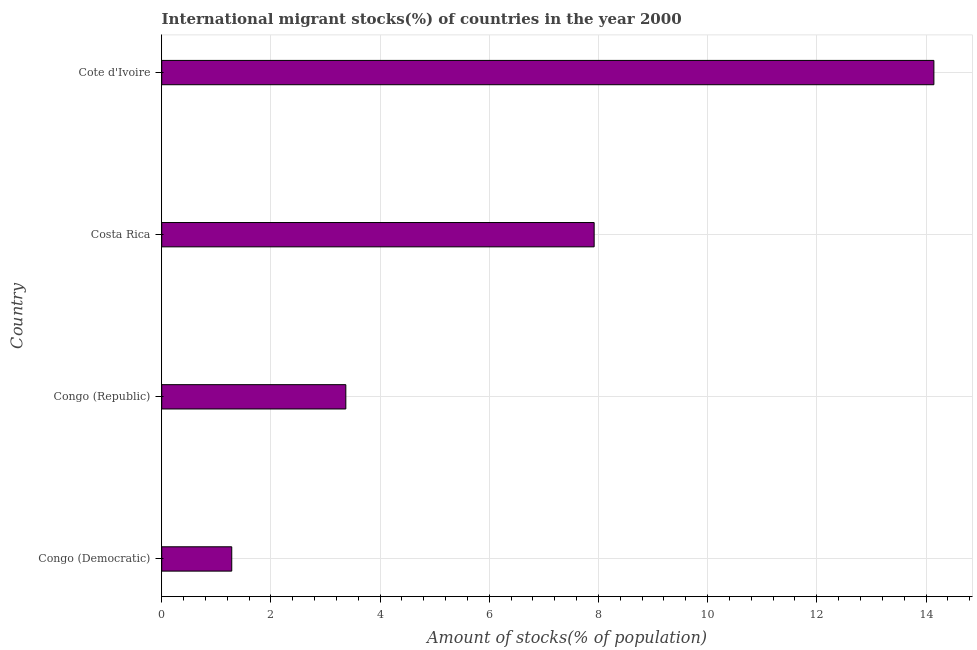What is the title of the graph?
Give a very brief answer. International migrant stocks(%) of countries in the year 2000. What is the label or title of the X-axis?
Your answer should be compact. Amount of stocks(% of population). What is the number of international migrant stocks in Congo (Republic)?
Your response must be concise. 3.37. Across all countries, what is the maximum number of international migrant stocks?
Ensure brevity in your answer.  14.14. Across all countries, what is the minimum number of international migrant stocks?
Provide a succinct answer. 1.28. In which country was the number of international migrant stocks maximum?
Your answer should be compact. Cote d'Ivoire. In which country was the number of international migrant stocks minimum?
Offer a terse response. Congo (Democratic). What is the sum of the number of international migrant stocks?
Keep it short and to the point. 26.72. What is the difference between the number of international migrant stocks in Costa Rica and Cote d'Ivoire?
Provide a succinct answer. -6.22. What is the average number of international migrant stocks per country?
Your response must be concise. 6.68. What is the median number of international migrant stocks?
Offer a terse response. 5.65. In how many countries, is the number of international migrant stocks greater than 1.2 %?
Make the answer very short. 4. What is the ratio of the number of international migrant stocks in Costa Rica to that in Cote d'Ivoire?
Ensure brevity in your answer.  0.56. Is the number of international migrant stocks in Congo (Democratic) less than that in Cote d'Ivoire?
Make the answer very short. Yes. Is the difference between the number of international migrant stocks in Congo (Republic) and Costa Rica greater than the difference between any two countries?
Your answer should be compact. No. What is the difference between the highest and the second highest number of international migrant stocks?
Give a very brief answer. 6.22. Is the sum of the number of international migrant stocks in Congo (Republic) and Cote d'Ivoire greater than the maximum number of international migrant stocks across all countries?
Provide a short and direct response. Yes. What is the difference between the highest and the lowest number of international migrant stocks?
Your answer should be very brief. 12.86. What is the difference between two consecutive major ticks on the X-axis?
Provide a succinct answer. 2. Are the values on the major ticks of X-axis written in scientific E-notation?
Keep it short and to the point. No. What is the Amount of stocks(% of population) of Congo (Democratic)?
Your answer should be compact. 1.28. What is the Amount of stocks(% of population) of Congo (Republic)?
Your answer should be compact. 3.37. What is the Amount of stocks(% of population) in Costa Rica?
Ensure brevity in your answer.  7.92. What is the Amount of stocks(% of population) in Cote d'Ivoire?
Your response must be concise. 14.14. What is the difference between the Amount of stocks(% of population) in Congo (Democratic) and Congo (Republic)?
Offer a very short reply. -2.09. What is the difference between the Amount of stocks(% of population) in Congo (Democratic) and Costa Rica?
Ensure brevity in your answer.  -6.64. What is the difference between the Amount of stocks(% of population) in Congo (Democratic) and Cote d'Ivoire?
Your response must be concise. -12.86. What is the difference between the Amount of stocks(% of population) in Congo (Republic) and Costa Rica?
Provide a succinct answer. -4.55. What is the difference between the Amount of stocks(% of population) in Congo (Republic) and Cote d'Ivoire?
Provide a succinct answer. -10.77. What is the difference between the Amount of stocks(% of population) in Costa Rica and Cote d'Ivoire?
Offer a terse response. -6.22. What is the ratio of the Amount of stocks(% of population) in Congo (Democratic) to that in Congo (Republic)?
Your answer should be compact. 0.38. What is the ratio of the Amount of stocks(% of population) in Congo (Democratic) to that in Costa Rica?
Offer a very short reply. 0.16. What is the ratio of the Amount of stocks(% of population) in Congo (Democratic) to that in Cote d'Ivoire?
Give a very brief answer. 0.09. What is the ratio of the Amount of stocks(% of population) in Congo (Republic) to that in Costa Rica?
Your answer should be very brief. 0.43. What is the ratio of the Amount of stocks(% of population) in Congo (Republic) to that in Cote d'Ivoire?
Provide a short and direct response. 0.24. What is the ratio of the Amount of stocks(% of population) in Costa Rica to that in Cote d'Ivoire?
Offer a very short reply. 0.56. 